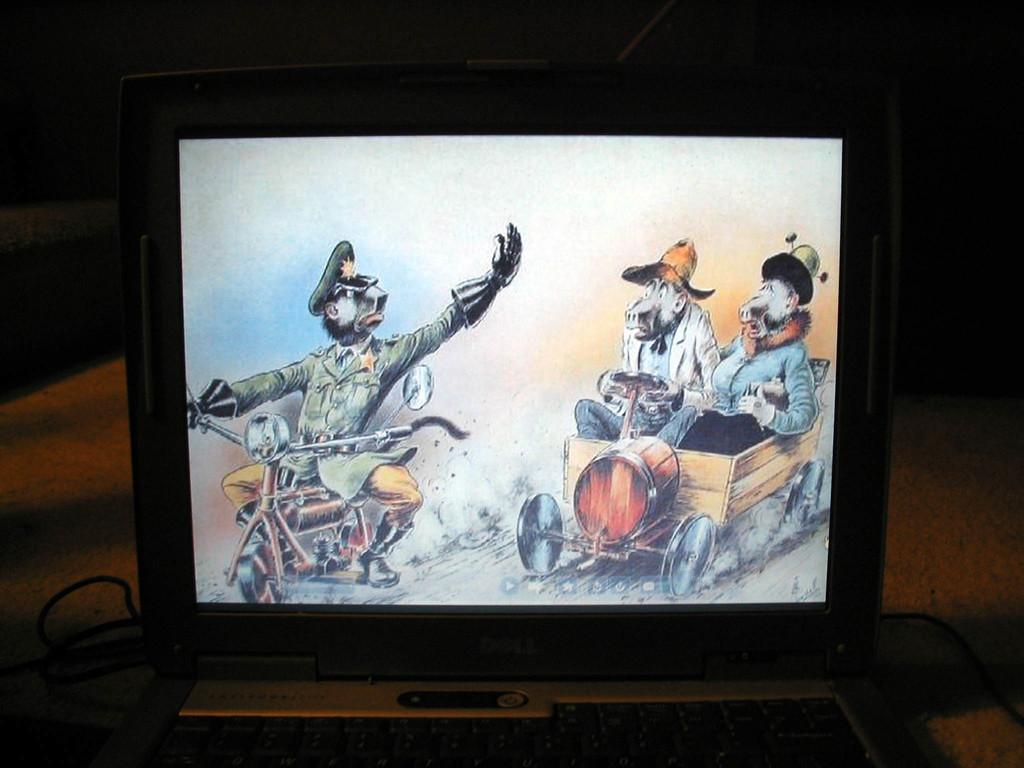Provide a one-sentence caption for the provided image. A dell laptops its in a dark room with a movie being played. 